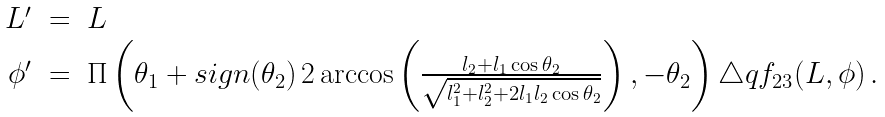<formula> <loc_0><loc_0><loc_500><loc_500>\begin{array} { r c l } L ^ { \prime } & = & L \\ \phi ^ { \prime } & = & \Pi \left ( \theta _ { 1 } + s i g n ( \theta _ { 2 } ) \, 2 \arccos \left ( \frac { l _ { 2 } + l _ { 1 } \cos \theta _ { 2 } } { \sqrt { l _ { 1 } ^ { 2 } + l _ { 2 } ^ { 2 } + 2 l _ { 1 } l _ { 2 } \cos \theta _ { 2 } } } \right ) , - \theta _ { 2 } \right ) \triangle q f _ { 2 3 } ( L , \phi ) \, . \end{array}</formula> 